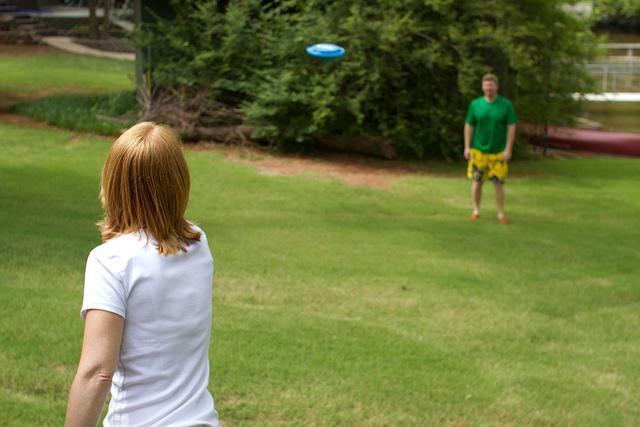How many people are in the photo?
Give a very brief answer. 2. 